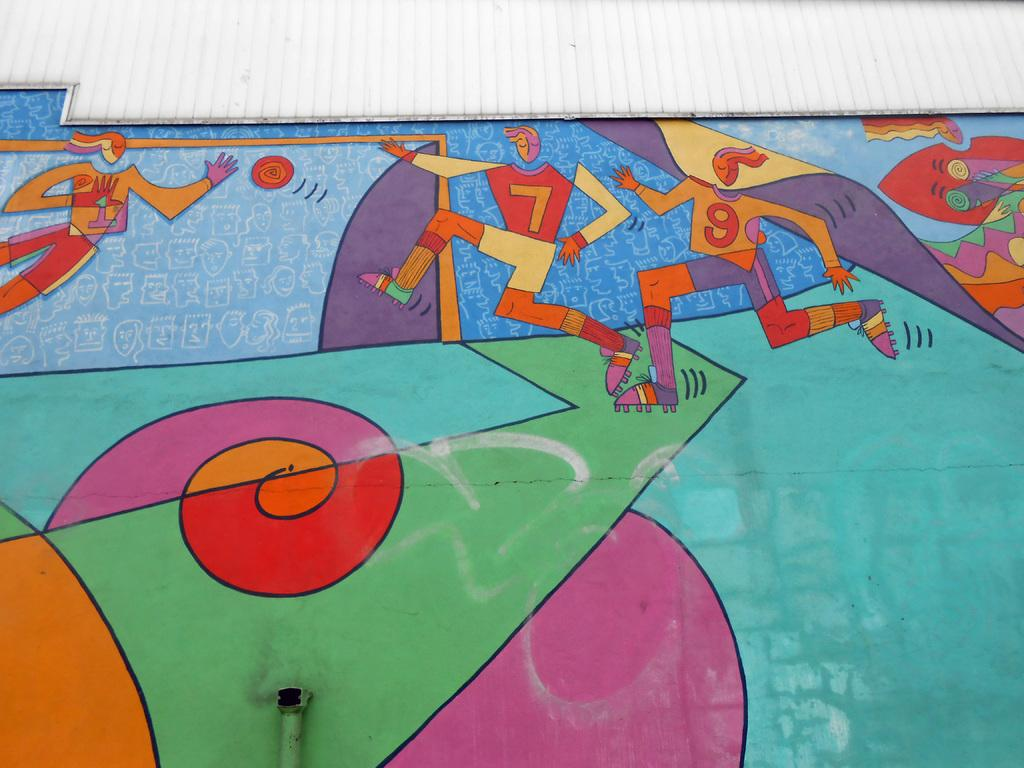What is present on the wall in the image? There is a painting on the wall in the image. What does the painting depict? The painting depicts cartoon people. What type of cord is used to hang the painting in the image? There is no cord visible in the image; the painting is directly attached to the wall. 